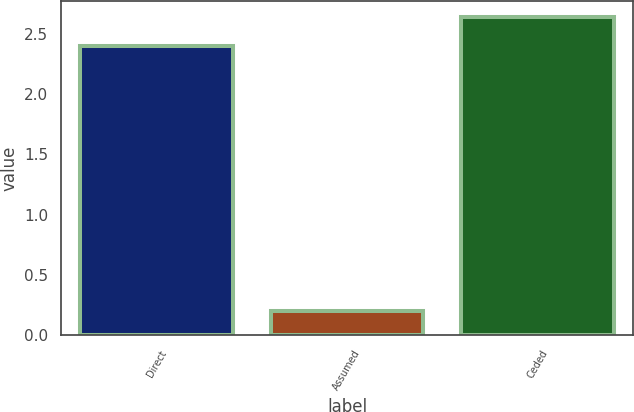Convert chart to OTSL. <chart><loc_0><loc_0><loc_500><loc_500><bar_chart><fcel>Direct<fcel>Assumed<fcel>Ceded<nl><fcel>2.4<fcel>0.2<fcel>2.64<nl></chart> 